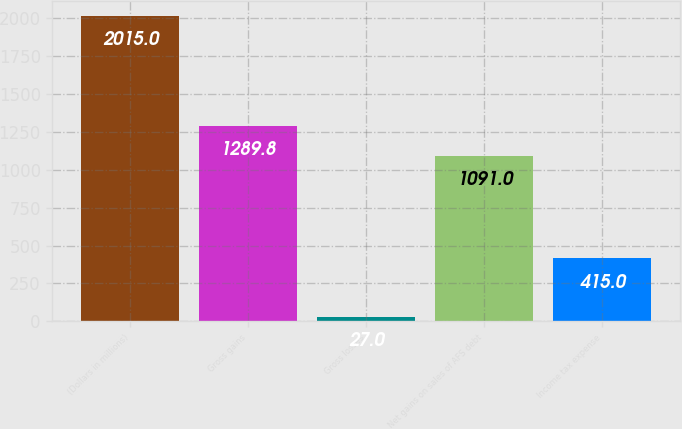<chart> <loc_0><loc_0><loc_500><loc_500><bar_chart><fcel>(Dollars in millions)<fcel>Gross gains<fcel>Gross losses<fcel>Net gains on sales of AFS debt<fcel>Income tax expense<nl><fcel>2015<fcel>1289.8<fcel>27<fcel>1091<fcel>415<nl></chart> 